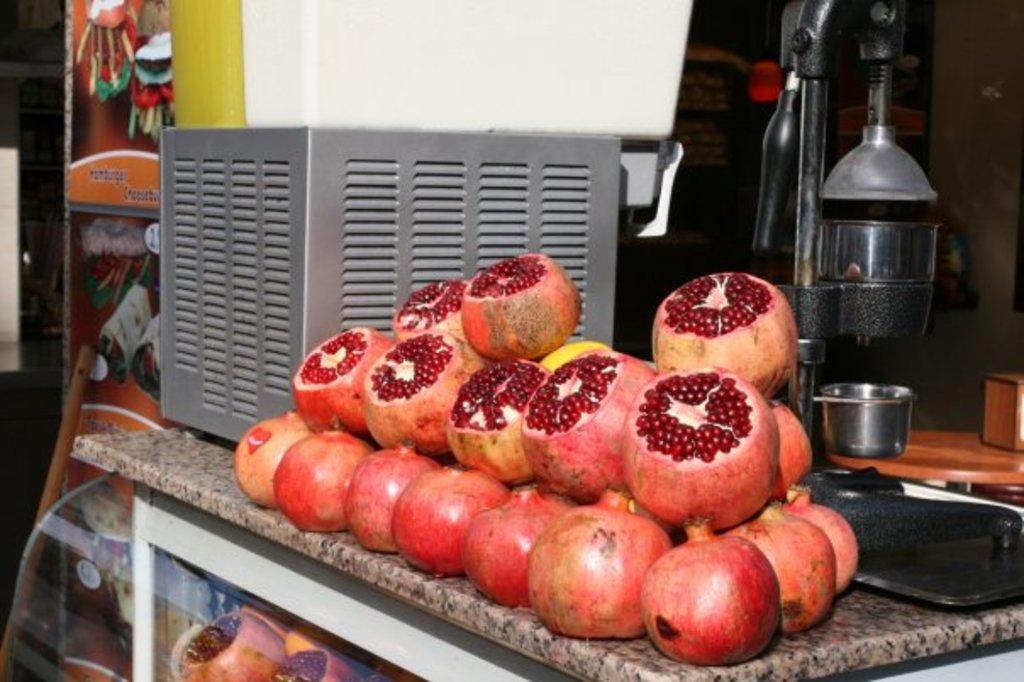In one or two sentences, can you explain what this image depicts? In this image we can see a cabinet. On the cabinet there are pomegranates and a juicer. 